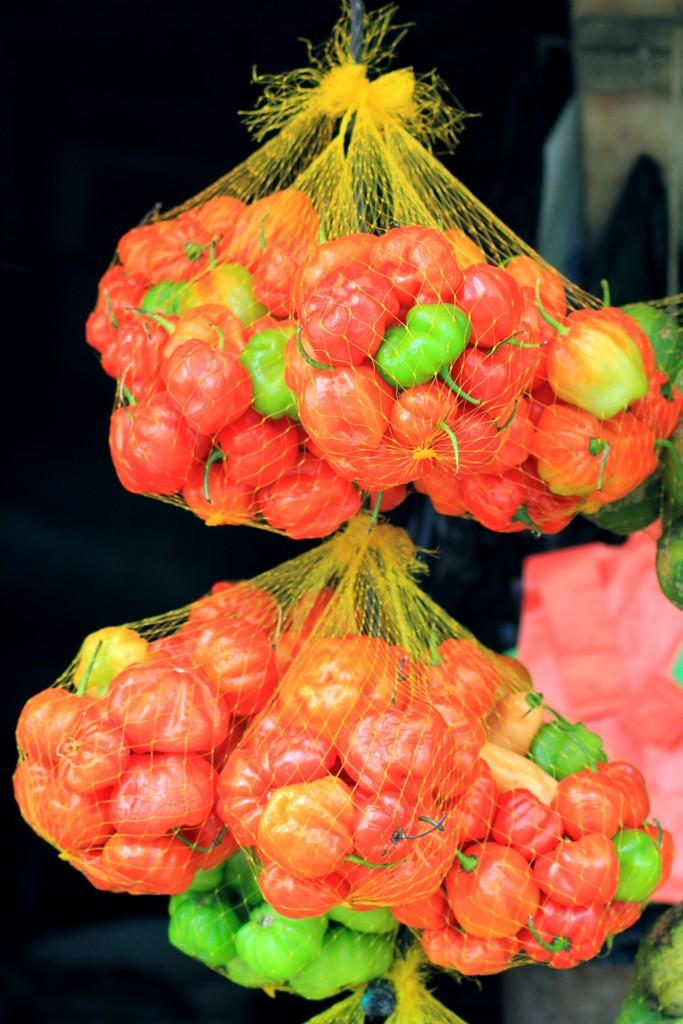What type of food items are present in the image? There are vegetables in the image. How are the vegetables arranged or contained? The vegetables are packed in nets. What colors can be observed in the vegetables? The vegetables have red and green colors. What is the color of the background in the image? The background of the image is dark. What type of map can be seen in the image? There is no map present in the image; it features vegetables packed in nets. What color is the pig in the image? There is no pig present in the image; it features vegetables packed in nets. 